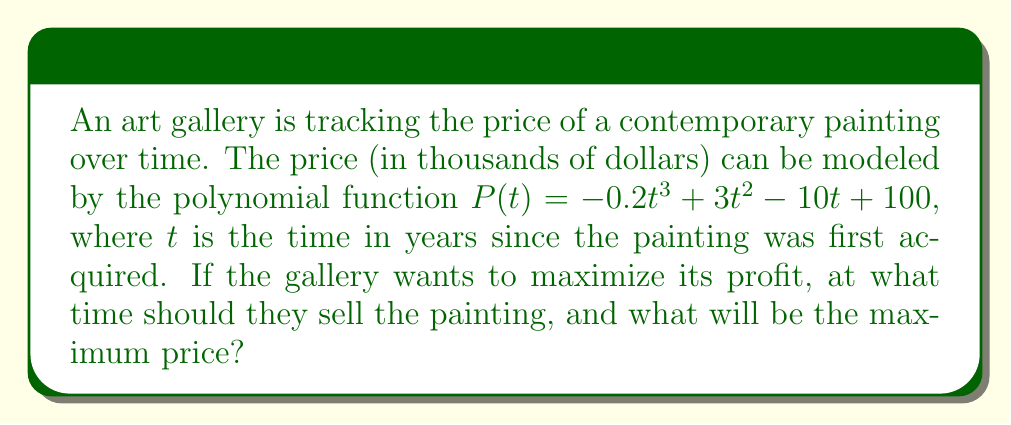Could you help me with this problem? To find the maximum price and when to sell the painting, we need to find the local maximum of the polynomial function $P(t)$. This occurs where the first derivative of $P(t)$ is zero and the second derivative is negative.

1. Find the first derivative:
   $$P'(t) = -0.6t^2 + 6t - 10$$

2. Set $P'(t) = 0$ and solve for $t$:
   $$-0.6t^2 + 6t - 10 = 0$$
   This is a quadratic equation. We can solve it using the quadratic formula:
   $$t = \frac{-b \pm \sqrt{b^2 - 4ac}}{2a}$$
   where $a = -0.6$, $b = 6$, and $c = -10$

3. Plugging in the values:
   $$t = \frac{-6 \pm \sqrt{36 - 4(-0.6)(-10)}}{2(-0.6)}$$
   $$t = \frac{-6 \pm \sqrt{36 - 24}}{-1.2}$$
   $$t = \frac{-6 \pm \sqrt{12}}{-1.2}$$
   $$t = \frac{-6 \pm 2\sqrt{3}}{-1.2}$$

4. This gives us two solutions:
   $$t_1 = \frac{-6 + 2\sqrt{3}}{-1.2} \approx 6.45$$
   $$t_2 = \frac{-6 - 2\sqrt{3}}{-1.2} \approx 3.55$$

5. To determine which solution gives us the maximum, we need to check the second derivative:
   $$P''(t) = -1.2t + 6$$

6. Evaluating $P''(t)$ at both points:
   $$P''(3.55) \approx -1.2(3.55) + 6 \approx 1.74 > 0$$
   $$P''(6.45) \approx -1.2(6.45) + 6 \approx -1.74 < 0$$

   Since $P''(6.45) < 0$, this is the point of local maximum.

7. To find the maximum price, we substitute $t = 6.45$ into the original function:
   $$P(6.45) = -0.2(6.45)^3 + 3(6.45)^2 - 10(6.45) + 100 \approx 115.35$$

Therefore, the gallery should sell the painting after approximately 6.45 years to maximize their profit, and the maximum price will be about $115,350.
Answer: The gallery should sell the painting after approximately 6.45 years, and the maximum price will be about $115,350. 